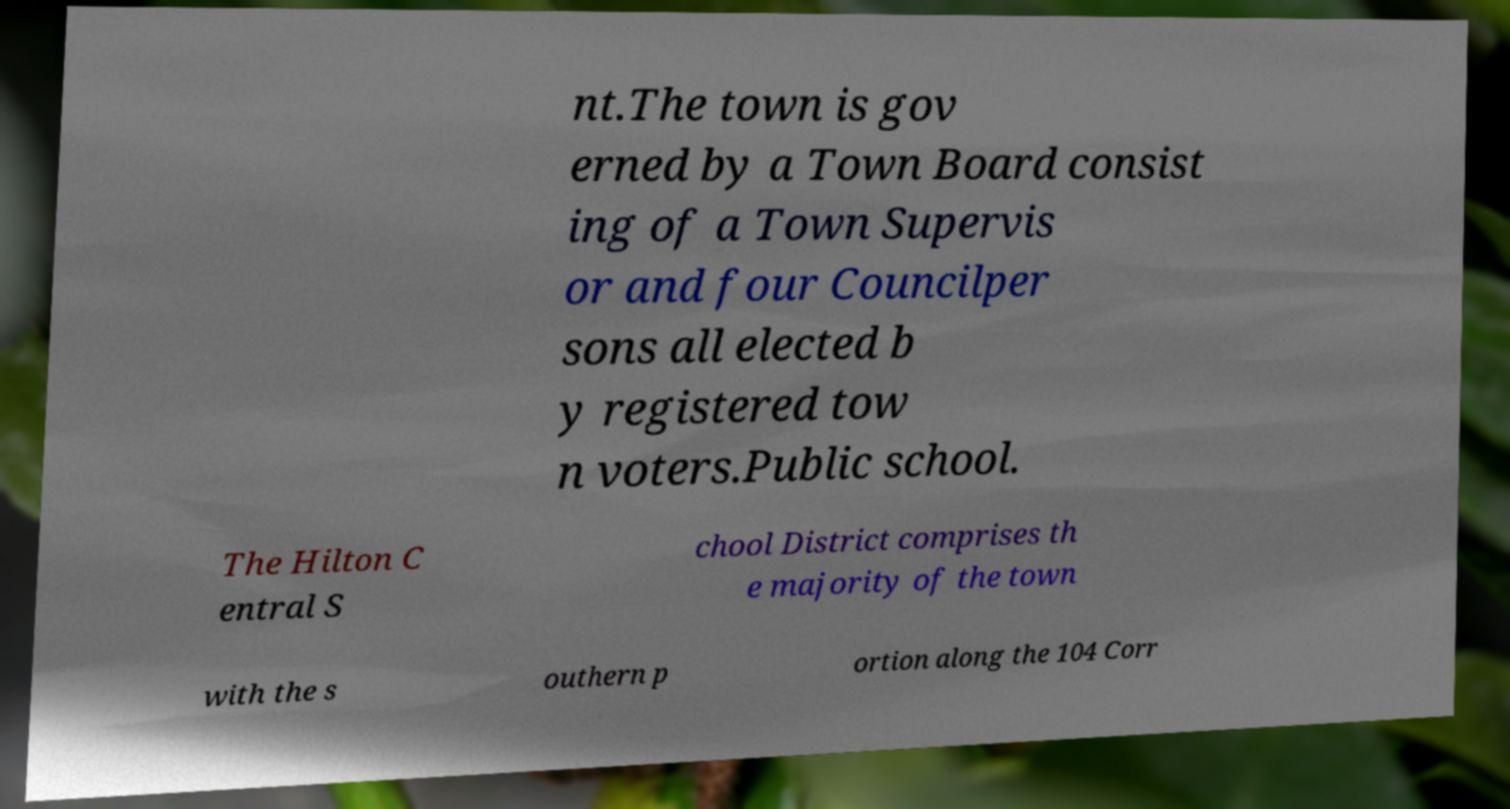Can you accurately transcribe the text from the provided image for me? nt.The town is gov erned by a Town Board consist ing of a Town Supervis or and four Councilper sons all elected b y registered tow n voters.Public school. The Hilton C entral S chool District comprises th e majority of the town with the s outhern p ortion along the 104 Corr 